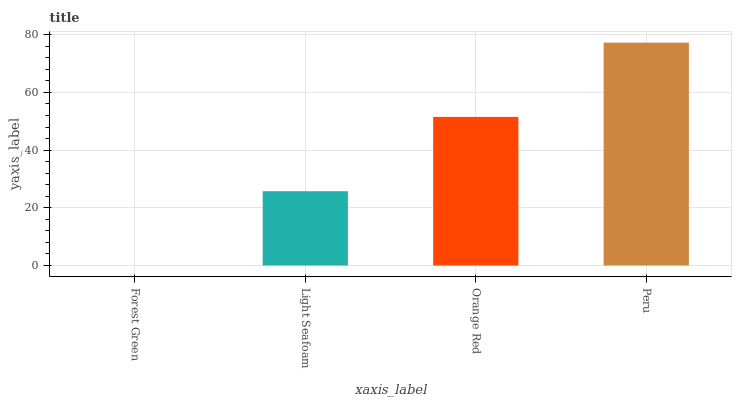Is Light Seafoam the minimum?
Answer yes or no. No. Is Light Seafoam the maximum?
Answer yes or no. No. Is Light Seafoam greater than Forest Green?
Answer yes or no. Yes. Is Forest Green less than Light Seafoam?
Answer yes or no. Yes. Is Forest Green greater than Light Seafoam?
Answer yes or no. No. Is Light Seafoam less than Forest Green?
Answer yes or no. No. Is Orange Red the high median?
Answer yes or no. Yes. Is Light Seafoam the low median?
Answer yes or no. Yes. Is Peru the high median?
Answer yes or no. No. Is Forest Green the low median?
Answer yes or no. No. 